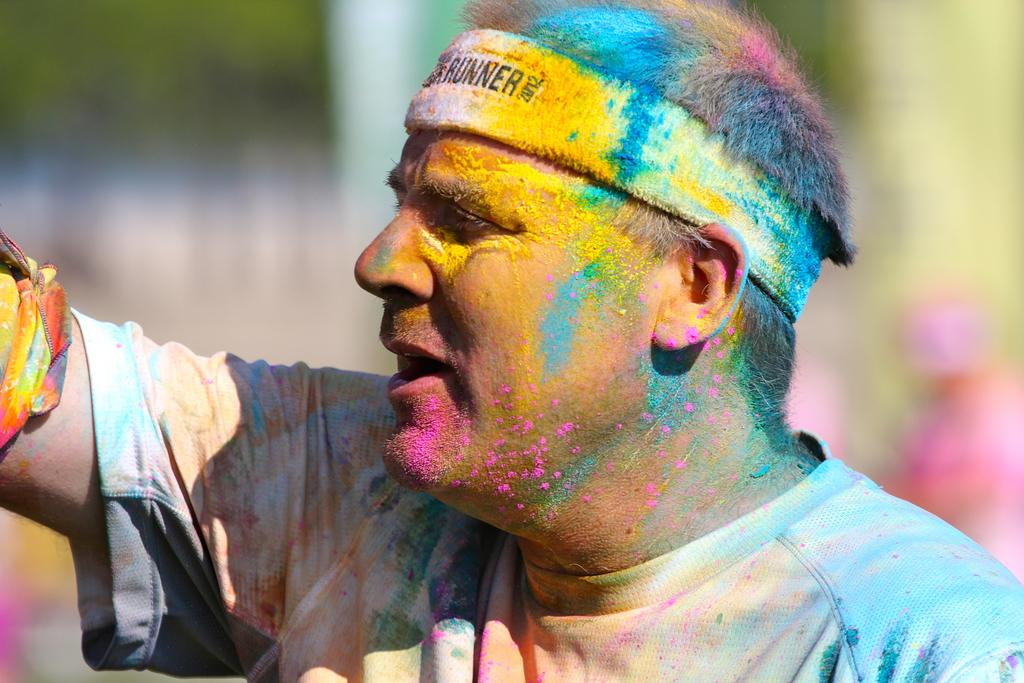What is the main subject of the picture? The main subject of the picture is a man. What is the man wearing in the picture? The man is wearing a t-shirt in the picture. Can you describe the man's appearance in the picture? The man's body has visible colors in the picture. What can be seen in the background of the picture? There is a blurred image in the background of the picture. What level of experience does the man have with biting in the image? There is no indication of the man biting anything in the image, so it cannot be determined from the picture. 